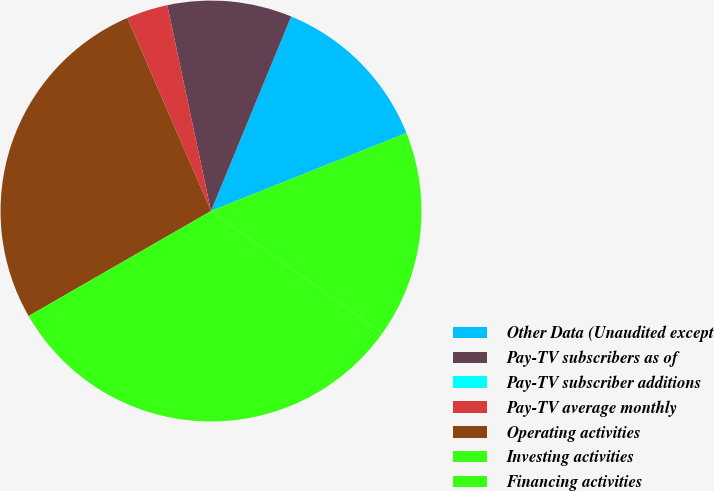<chart> <loc_0><loc_0><loc_500><loc_500><pie_chart><fcel>Other Data (Unaudited except<fcel>Pay-TV subscribers as of<fcel>Pay-TV subscriber additions<fcel>Pay-TV average monthly<fcel>Operating activities<fcel>Investing activities<fcel>Financing activities<nl><fcel>12.73%<fcel>9.55%<fcel>0.0%<fcel>3.18%<fcel>26.8%<fcel>31.82%<fcel>15.91%<nl></chart> 